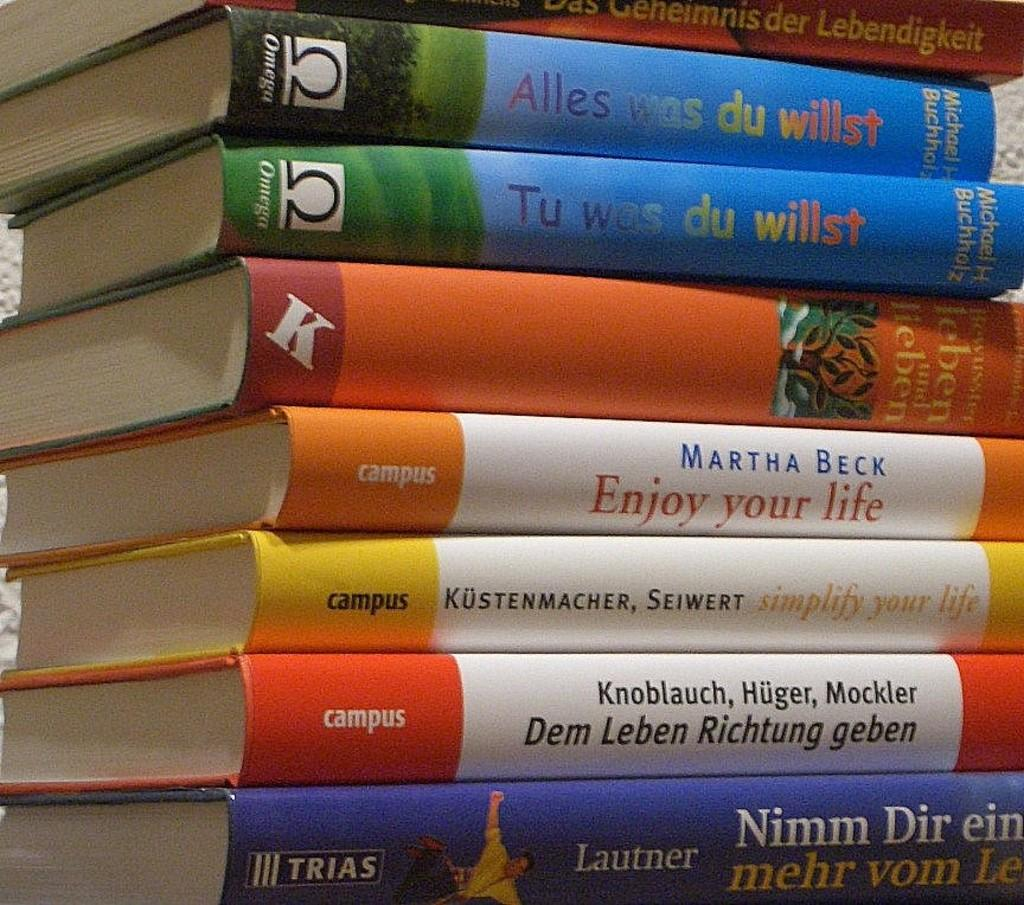Provide a one-sentence caption for the provided image. A pile of books, the top two are called Alles Was Du Willst. 